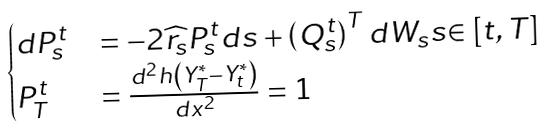<formula> <loc_0><loc_0><loc_500><loc_500>\begin{cases} d P _ { s } ^ { t } & = - 2 \widehat { r _ { s } } P _ { s } ^ { t } d s + \left ( Q _ { s } ^ { t } \right ) ^ { T } d W _ { s } s { \in \left [ t , T \right ] } \\ P _ { T } ^ { t } & = \frac { d ^ { 2 } h \left ( Y _ { T } ^ { * } - Y _ { t } ^ { * } \right ) } { d x ^ { 2 } } = 1 \end{cases}</formula> 